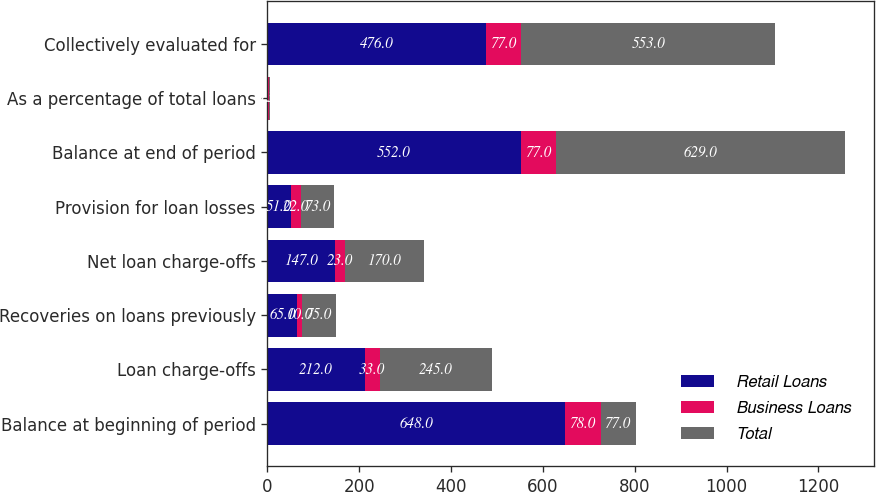Convert chart to OTSL. <chart><loc_0><loc_0><loc_500><loc_500><stacked_bar_chart><ecel><fcel>Balance at beginning of period<fcel>Loan charge-offs<fcel>Recoveries on loans previously<fcel>Net loan charge-offs<fcel>Provision for loan losses<fcel>Balance at end of period<fcel>As a percentage of total loans<fcel>Collectively evaluated for<nl><fcel>Retail Loans<fcel>648<fcel>212<fcel>65<fcel>147<fcel>51<fcel>552<fcel>1.3<fcel>476<nl><fcel>Business Loans<fcel>78<fcel>33<fcel>10<fcel>23<fcel>22<fcel>77<fcel>2.1<fcel>77<nl><fcel>Total<fcel>77<fcel>245<fcel>75<fcel>170<fcel>73<fcel>629<fcel>1.37<fcel>553<nl></chart> 